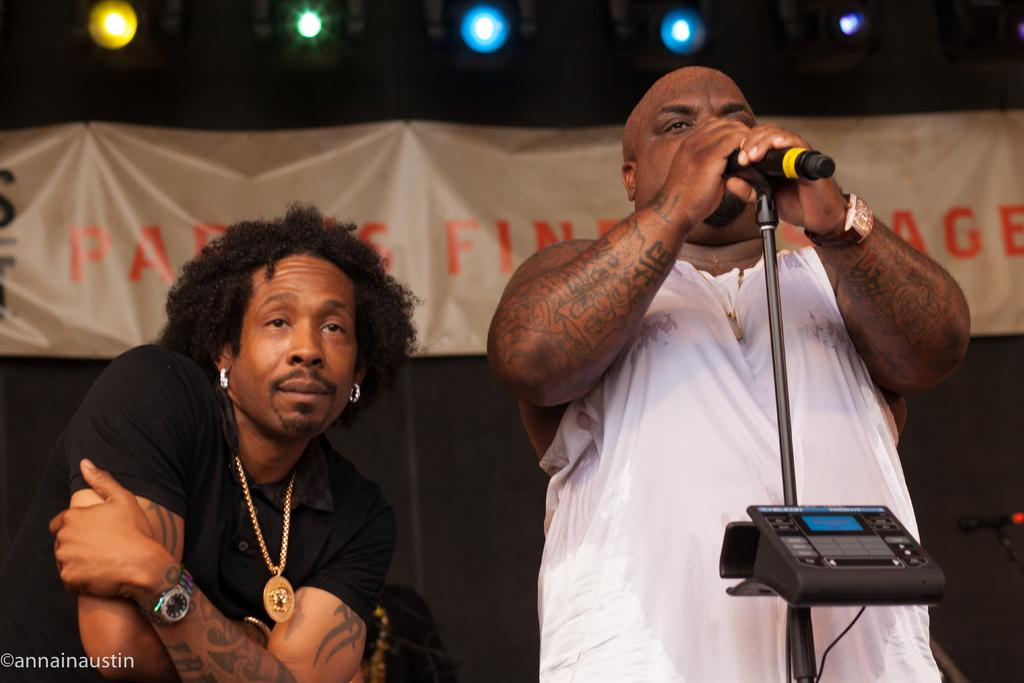How many people are in the image? There are two persons in the image. What is one person doing in the image? One person is standing. What is the standing person holding? The standing person is holding a microphone with a stand. What can be seen in the background of the image? There is a banner in the background of the image. What type of lighting is present in the image? Focusing lights are present in the image. Can you tell me if the wax has melted on the microphone stand in the image? There is no wax present on the microphone stand in the image. What type of lift is being used in the image? There is no lift being used in the image. 